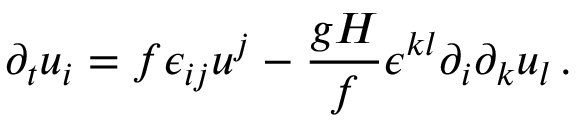<formula> <loc_0><loc_0><loc_500><loc_500>\partial _ { t } { u } _ { i } = f \epsilon _ { i j } u ^ { j } - \frac { g H } { f } \epsilon ^ { k l } \partial _ { i } \partial _ { k } u _ { l } \, .</formula> 